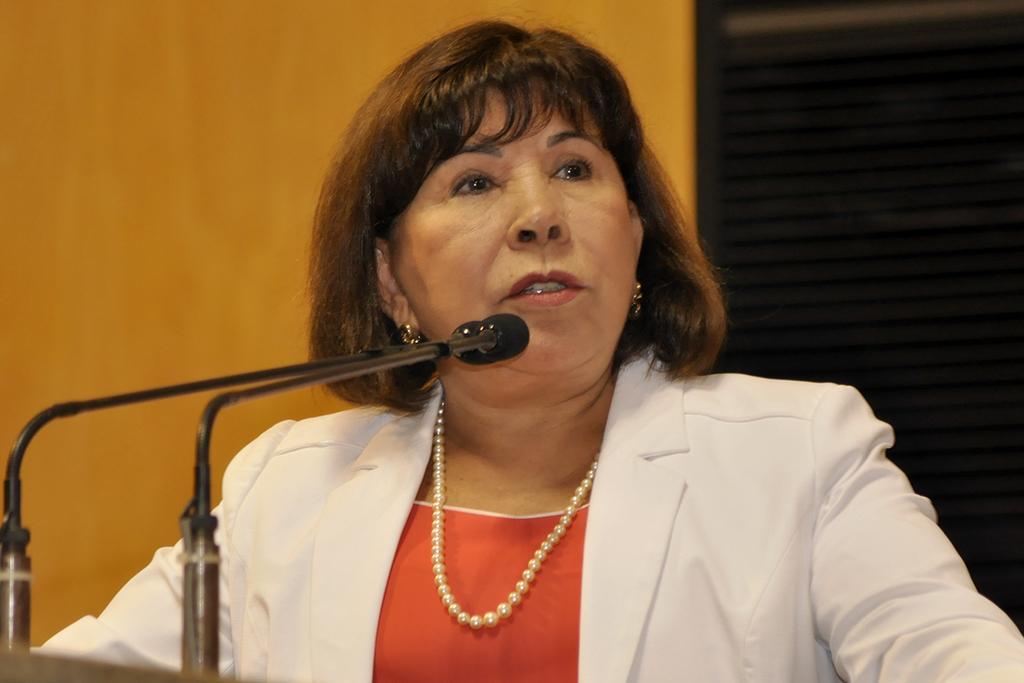Can you describe this image briefly? The woman in front of the picture wearing a red dress and white blazer is talking on the microphone. In front of her, we see a microphone. On the right side, it is black in color. On the left side, it is orange in color. 